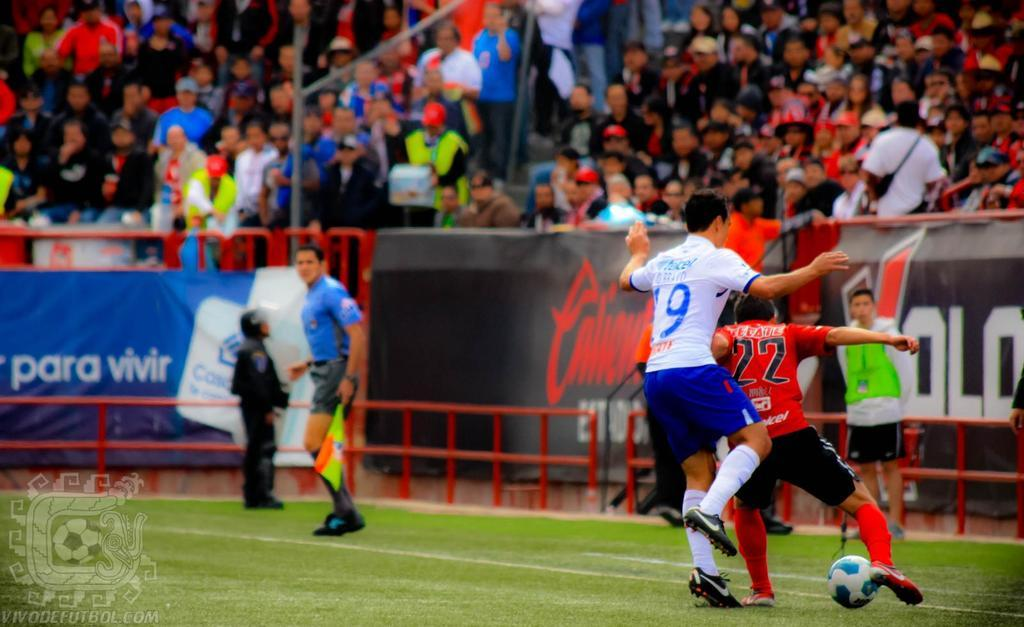What activity are the persons in the image engaged in? The persons in the image are playing football. What can be seen in the background of the image? There is a banner visible in the background. Are there any persons sitting in the image? Yes, there are persons sitting in the image. Are there any persons standing in the image? Yes, there are persons standing in the image. What type of creature can be seen reciting a verse in the image? There is no creature or verse present in the image; it features persons playing football and other individuals sitting or standing. 